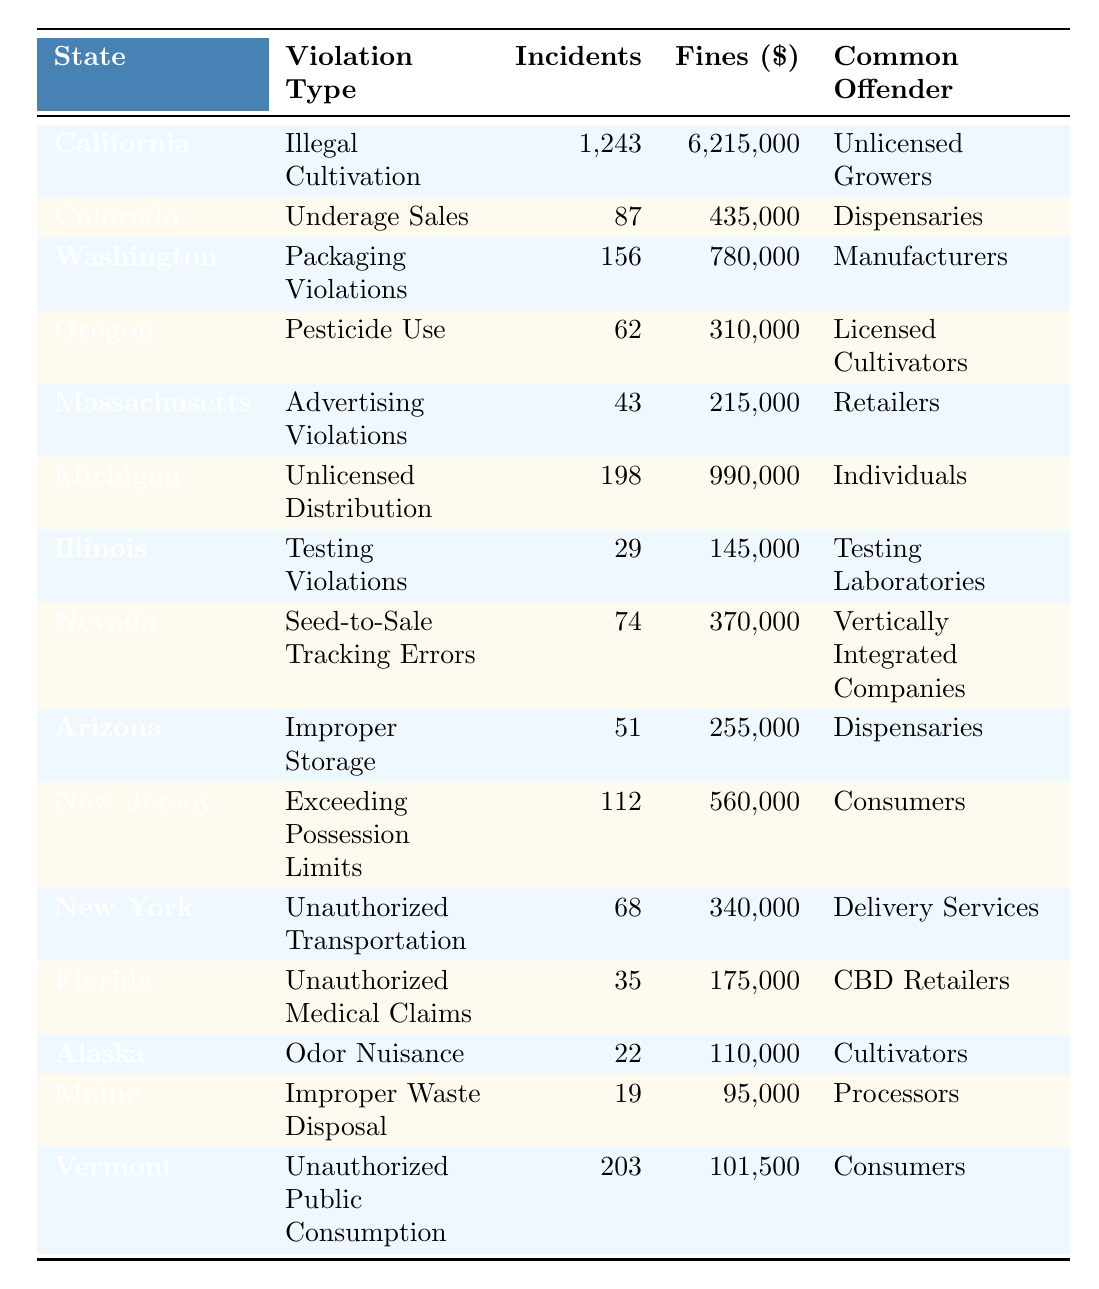What is the state with the highest number of illegal cultivation incidents? California has the highest number of illegal cultivation incidents, with 1,243. This is the only data point listed for that specific violation type in the table, making it clear that it holds the highest number.
Answer: California Which state had the lowest total fines due to cannabis legal violations? Maine had the lowest total fines of $95,000. By comparing the 'Total Fines ($)' column for all states, it is evident that Maine’s figure is the smallest.
Answer: Maine How many incidents of unauthorized transportation were reported in New York? The table lists that there were 68 incidents of unauthorized transportation in New York. This is directly mentioned under the appropriate violation type for that state.
Answer: 68 What is the total number of incidents reported for all listed violations in the table? To calculate the total incidents, sum all values from the 'Number of Incidents' column: 1243 + 87 + 156 + 62 + 43 + 198 + 29 + 74 + 51 + 112 + 68 + 35 + 22 + 19 + 203 = 2,219. This total represents the overall incidents across all states.
Answer: 2219 Which state recorded the most common offender type as "Consumers"? Vermont and New Jersey both list "Consumers" as their most common offender type. The table shows Vermont with unauthorized public consumption and New Jersey with exceeding possession limits, relating them both to consumers.
Answer: Vermont and New Jersey Is Oregon associated with packaging violations? No, Oregon is not listed under packaging violations, as it reports pesticide use violations instead. The table confirms that packaging violations are attributed to Washington, thus making the statement false.
Answer: No What was the average total fines incurred for violations from the states listed? To find the average total fines, first sum all fines: 6215000 + 435000 + 780000 + 310000 + 215000 + 990000 + 145000 + 370000 + 255000 + 560000 + 340000 + 175000 + 110000 + 95000 + 101500 = 7,817,500. There are 15 data points (states), so the average would be 7817500 / 15 = 521167.33 (rounded off is approximately 521167).
Answer: Approximately 521167 Which violation type resulted in the highest total fines and how much were they? Illegal cultivation in California resulted in the highest total fines of $6,215,000. This can be identified by comparing the 'Total Fines ($)' across all violation types in the table.
Answer: $6,215,000 How many states documented testing violations? The table indicates that only Illinois reported testing violations, making it the sole state with this violation type. Thus, only one state is involved.
Answer: 1 What is the difference in total fines between the state with the highest incidents and the state with the lowest? California has the highest total fines of $6,215,000, and Maine has the lowest with $95,000. The difference is calculated as 6215000 - 95000 = 6,120,000. This shows the significant gap in fines incurred.
Answer: $6,120,000 